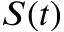Convert formula to latex. <formula><loc_0><loc_0><loc_500><loc_500>S ( t )</formula> 